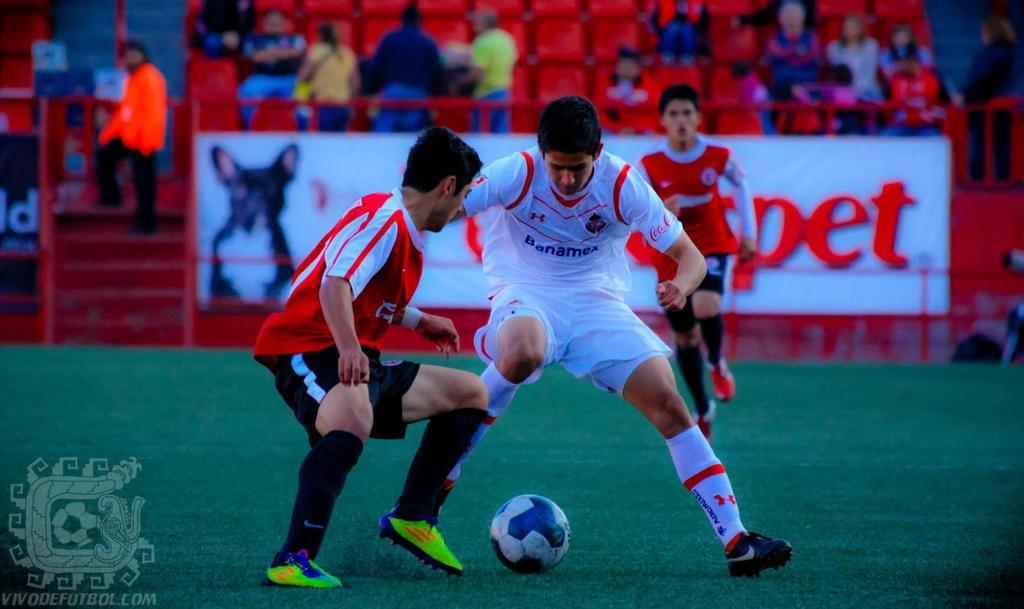<image>
Offer a succinct explanation of the picture presented. Some football players play in front of a sign reading Pet 